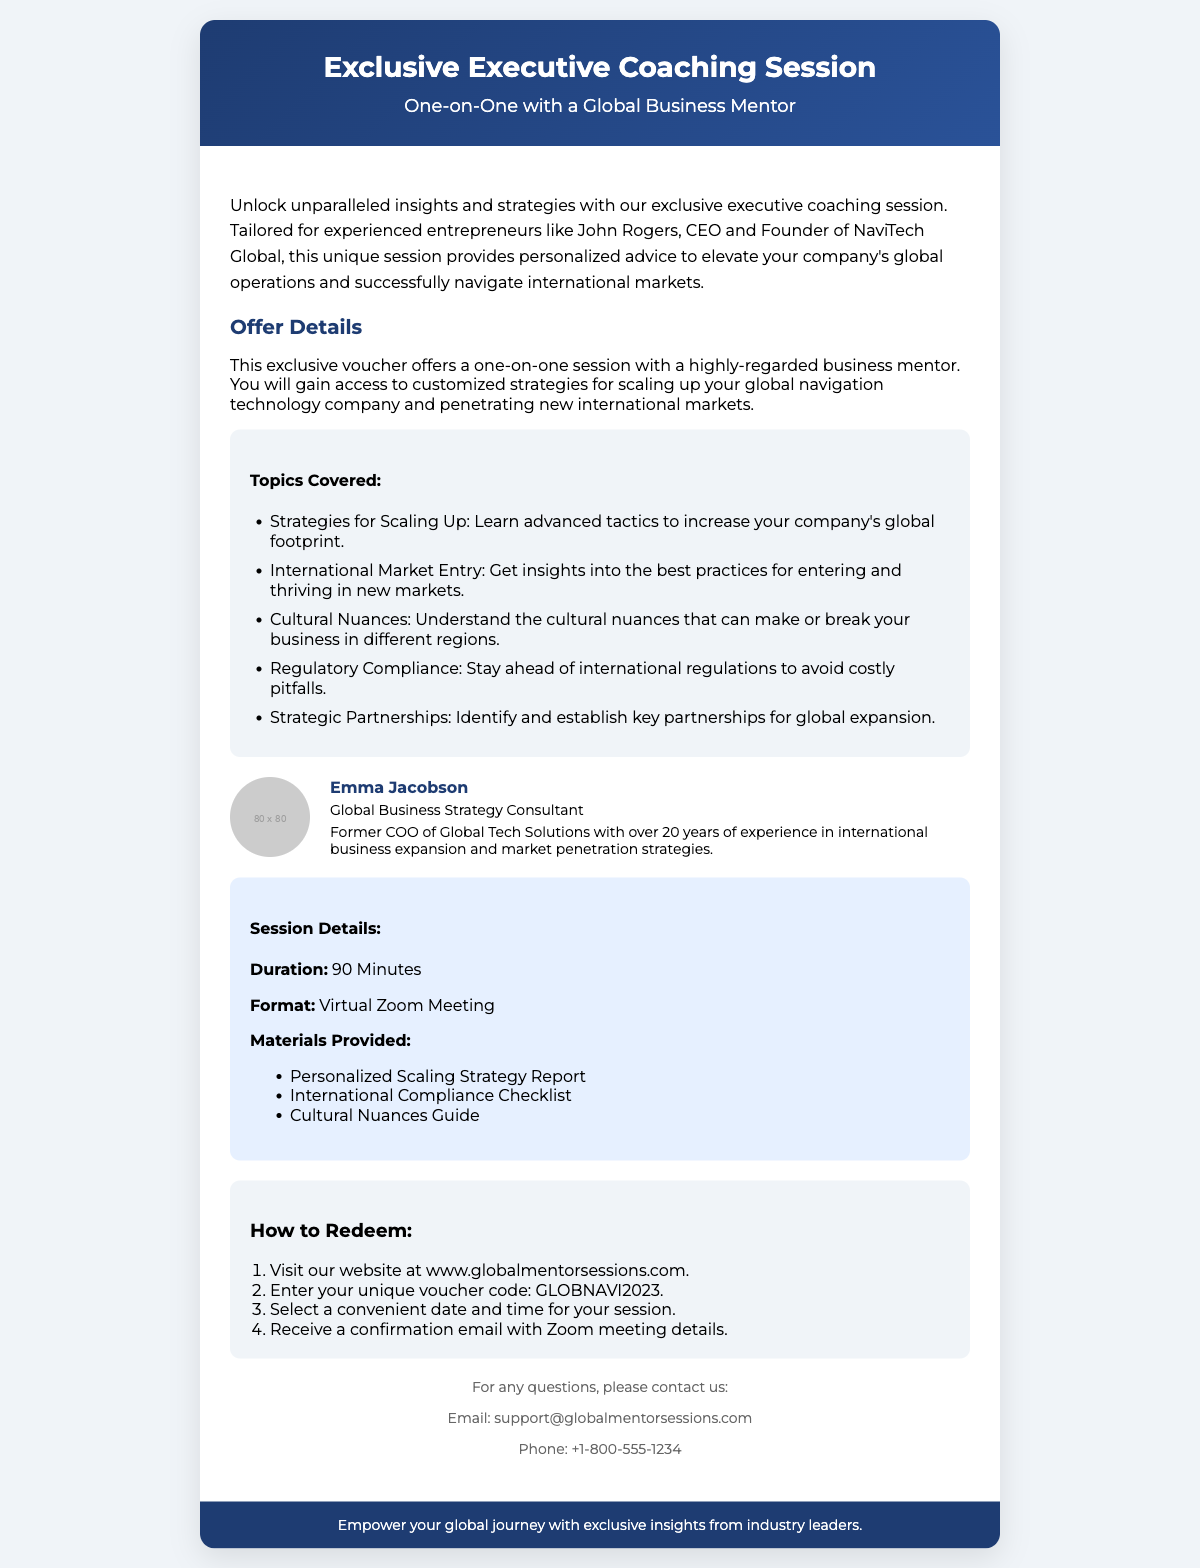What is the duration of the session? The duration of the session is specified in the session details section of the document.
Answer: 90 Minutes Who is the mentor for the session? The mentor's name is mentioned in the mentor section of the document.
Answer: Emma Jacobson What type of meeting format is used for the session? The format of the meeting is defined in the session details section.
Answer: Virtual Zoom Meeting What is the unique voucher code provided? The unique voucher code is presented in the redeem section of the document.
Answer: GLOBNAVI2023 What is one of the topics covered during the coaching session? Topics covered are listed under the topics covered section in the document.
Answer: Strategies for Scaling Up How many materials are provided after the session? The number of materials can be inferred from the list of materials provided in the session details section.
Answer: Three What is the profession of the mentor? The profession of the mentor is stated in the mentor section of the document.
Answer: Global Business Strategy Consultant What is the primary purpose of the coaching session? The purpose of the coaching session is outlined in the introductory paragraph.
Answer: Discuss strategies for scaling up global operations and navigating international markets 